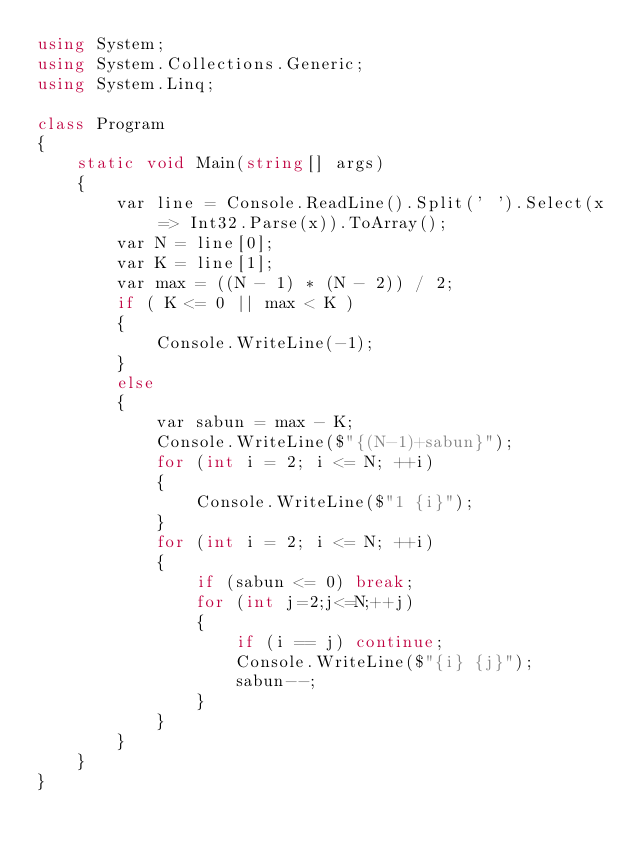<code> <loc_0><loc_0><loc_500><loc_500><_C#_>using System;
using System.Collections.Generic;
using System.Linq;

class Program
{
    static void Main(string[] args)
    {
        var line = Console.ReadLine().Split(' ').Select(x => Int32.Parse(x)).ToArray();
        var N = line[0];
        var K = line[1];
        var max = ((N - 1) * (N - 2)) / 2;
        if ( K <= 0 || max < K )
        {
            Console.WriteLine(-1);
        }
        else
        {
            var sabun = max - K;
            Console.WriteLine($"{(N-1)+sabun}");
            for (int i = 2; i <= N; ++i)
            {
                Console.WriteLine($"1 {i}");
            }
            for (int i = 2; i <= N; ++i)
            {
                if (sabun <= 0) break;
                for (int j=2;j<=N;++j)
                {
                    if (i == j) continue;
                    Console.WriteLine($"{i} {j}");
                    sabun--;
                }
            }
        }
    }
}

</code> 